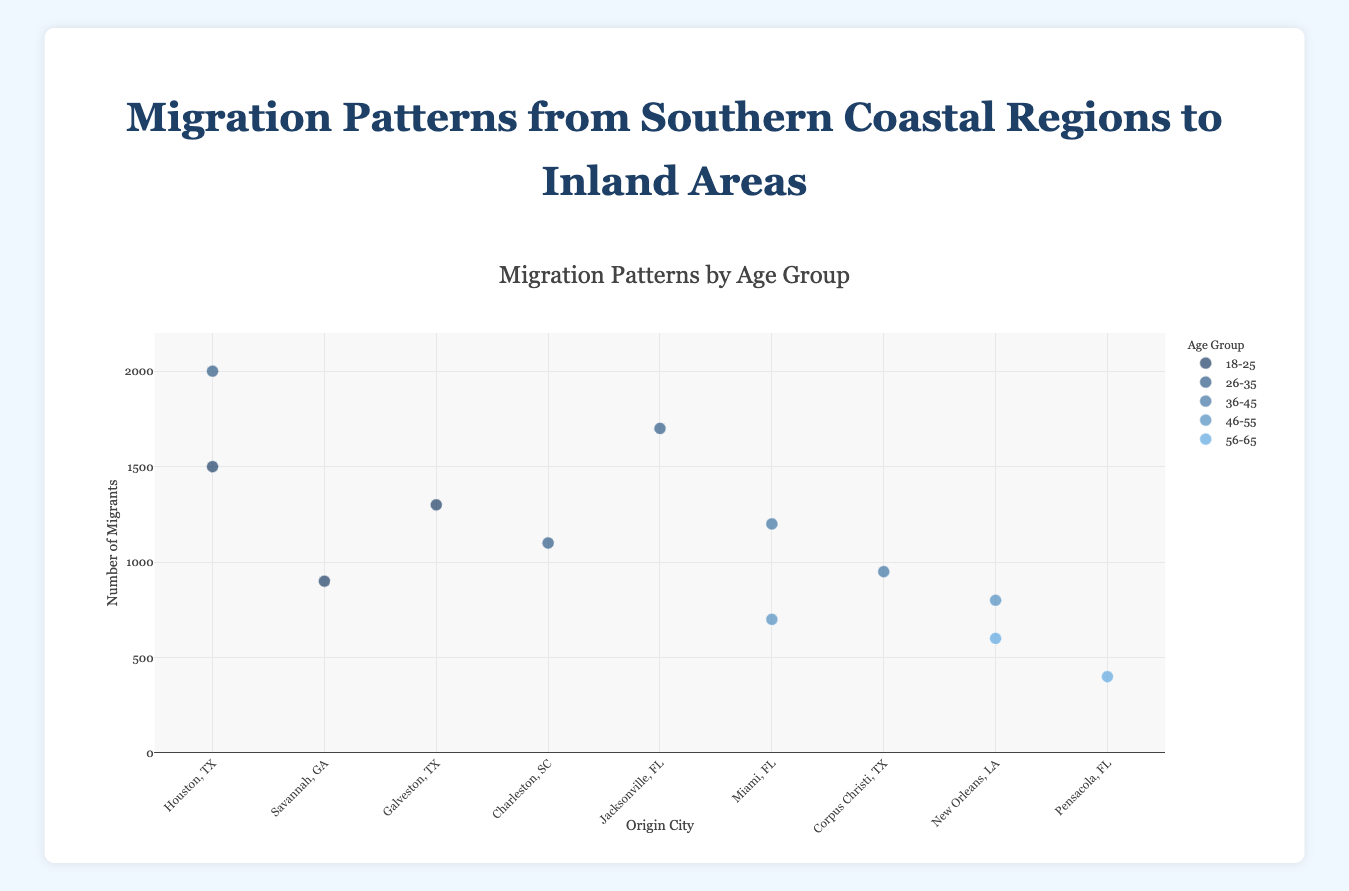What is the title of the figure? The title of the figure is written at the top center and reads "Migration Patterns from Southern Coastal Regions to Inland Areas by Age Group".
Answer: Migration Patterns from Southern Coastal Regions to Inland Areas by Age Group Which origin city has the highest number of migrants in the 26-35 age group? From the figure, observe the points for the 26-35 age group and identify the city with the highest y-axis value (representing the number of migrants). Houston, TX has the highest number of migrants in this age group with 2000 migrants.
Answer: Houston, TX What is the difference in the number of migrants between Miami, FL to Orlando, FL and New Orleans, LA to Baton Rouge, LA for the corresponding age groups? Compare the migrants for Miami, FL to Orlando, FL (age group 36-45, 1200 migrants) and New Orleans, LA to Baton Rouge, LA (age group 46-55, 800 migrants). Subtract 800 from 1200.
Answer: 400 How many origin cities have migrants in the 18-25 age group? Count the distinct origin cities for the age group 18-25. The cities are Houston, TX, Savannah, GA, and Galveston, TX, totaling three cities.
Answer: 3 Which destination has the smallest number of migrants, and what is the age group? Identify the point with the lowest y-axis value and check its corresponding text and age group. Pensacola, FL to Montgomery, AL in the age group 56-65 has the smallest number of migrants with 400 migrants.
Answer: Montgomery, AL, 56-65 Do any origin cities have migrations to multiple destinations within the same age group? Check if any origin cities have multiple destinations for the same age group by analyzing the scatter plot points visually. Houston, TX appears twice, but with different age groups. No origin city appears with multiple destinations in the same age group.
Answer: No Between the age group 36-45, which city has a higher number of migrants, Miami, FL or Corpus Christi, TX? Compare the points for Miami, FL to Orlando, FL (age group 36-45, 1200 migrants) and Corpus Christi, TX to San Antonio, TX (age group 36-45, 950 migrants). Miami, FL has a higher number.
Answer: Miami, FL What is the total number of migrants for the destination cities located in Florida? Sum up the number of migrants for destinations in Florida: Orlando (1200), Tallahassee (700), Gainesville (1700). The total is 1200 + 700 + 1700 = 3600.
Answer: 3600 Which age group has the most migrations from Houston, TX? Compare the points specifically for Houston, TX to see which age group has the highest y-axis value. The age group 26-35 has the highest migration count from Houston, TX with 2000 migrants.
Answer: 26-35 